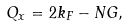Convert formula to latex. <formula><loc_0><loc_0><loc_500><loc_500>Q _ { x } = 2 k _ { F } - N G ,</formula> 